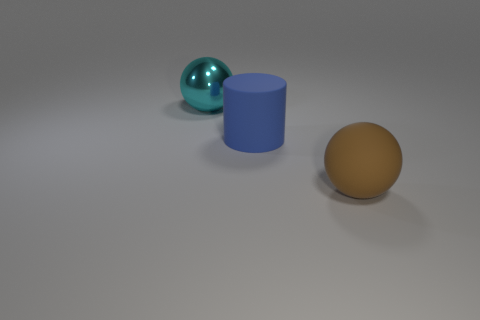Add 2 large green cylinders. How many objects exist? 5 Subtract all cylinders. How many objects are left? 2 Add 1 large blue cylinders. How many large blue cylinders exist? 2 Subtract 0 blue spheres. How many objects are left? 3 Subtract all large brown balls. Subtract all big cyan shiny things. How many objects are left? 1 Add 1 big blue cylinders. How many big blue cylinders are left? 2 